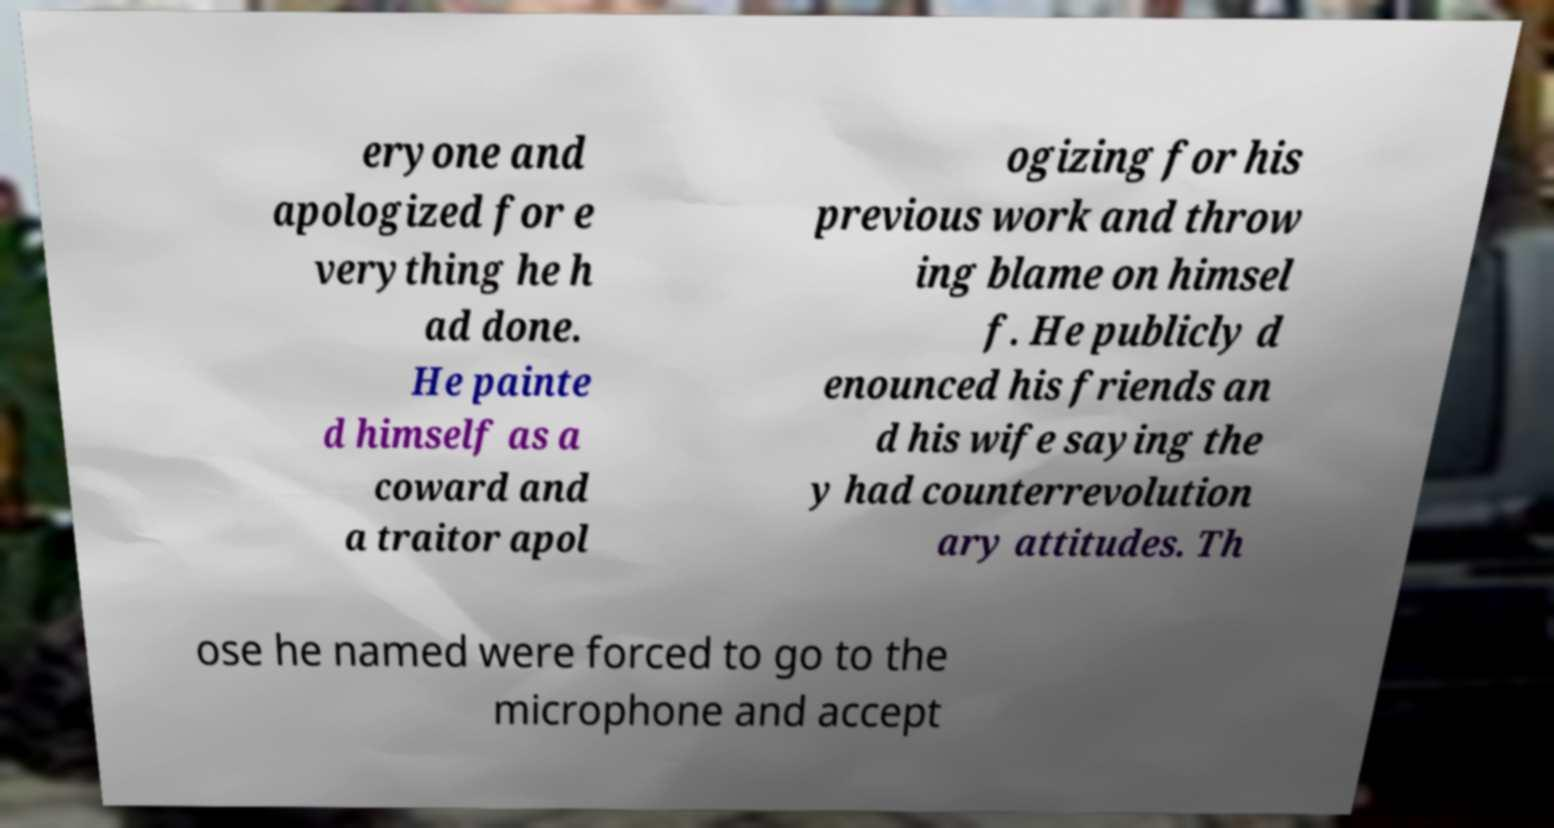Can you read and provide the text displayed in the image?This photo seems to have some interesting text. Can you extract and type it out for me? eryone and apologized for e verything he h ad done. He painte d himself as a coward and a traitor apol ogizing for his previous work and throw ing blame on himsel f. He publicly d enounced his friends an d his wife saying the y had counterrevolution ary attitudes. Th ose he named were forced to go to the microphone and accept 